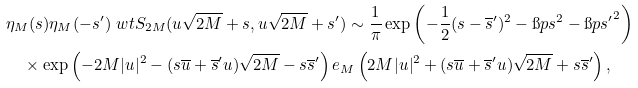Convert formula to latex. <formula><loc_0><loc_0><loc_500><loc_500>& \eta _ { M } ( s ) \eta _ { M } ( - s ^ { \prime } ) \ w t { S } _ { 2 M } ( u \sqrt { 2 M } + s , u \sqrt { 2 M } + s ^ { \prime } ) \sim \frac { 1 } { \pi } \exp \left ( - \frac { 1 } { 2 } ( s - \overline { s } ^ { \prime } ) ^ { 2 } - \i p s ^ { 2 } - \i p { s ^ { \prime } } ^ { 2 } \right ) \\ & \quad \times \exp \left ( - 2 M | u | ^ { 2 } - ( s \overline { u } + \overline { s } ^ { \prime } u ) \sqrt { 2 M } - s \overline { s } ^ { \prime } \right ) e _ { M } \left ( 2 M | u | ^ { 2 } + ( s \overline { u } + \overline { s } ^ { \prime } u ) \sqrt { 2 M } + s \overline { s } ^ { \prime } \right ) ,</formula> 